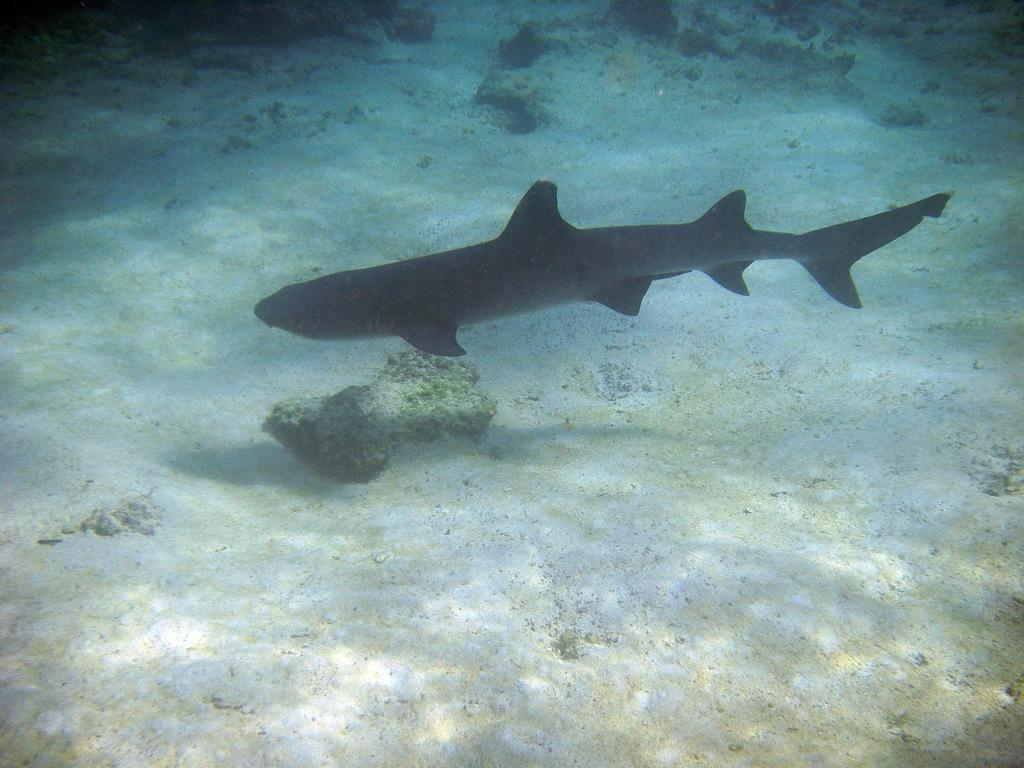What type of animal can be seen in the water in the image? There is a fish in the water in the image. What is at the bottom of the water? There is sand at the bottom of the water. What else can be found in the water besides the fish? There are stones in the water. What type of seat can be seen in the water in the image? There is no seat present in the water in the image. What color is the yarn used to create the fish in the image? The image does not depict a fish made of yarn, so there is no yarn to describe. 